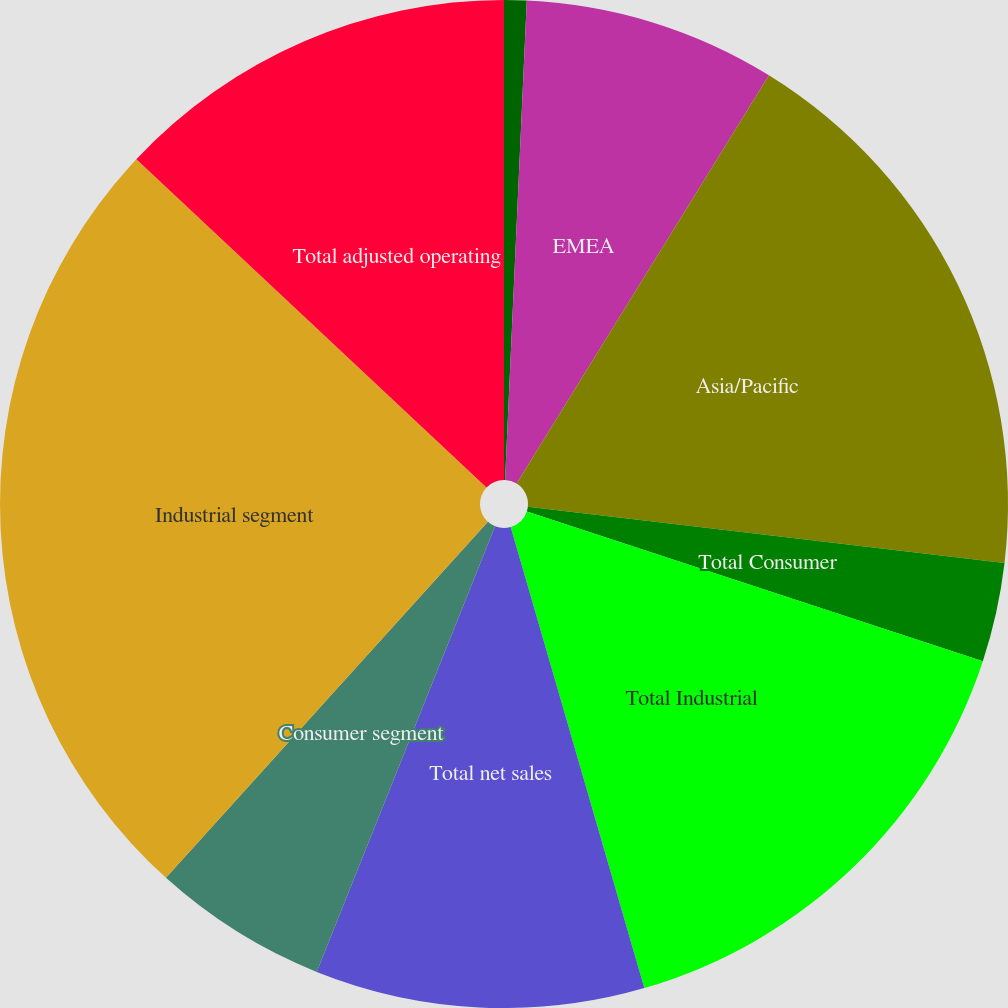Convert chart to OTSL. <chart><loc_0><loc_0><loc_500><loc_500><pie_chart><fcel>Americas<fcel>EMEA<fcel>Asia/Pacific<fcel>Total Consumer<fcel>Total Industrial<fcel>Total net sales<fcel>Consumer segment<fcel>Industrial segment<fcel>Total adjusted operating<nl><fcel>0.72%<fcel>8.09%<fcel>18.06%<fcel>3.18%<fcel>15.46%<fcel>10.55%<fcel>5.64%<fcel>25.29%<fcel>13.01%<nl></chart> 